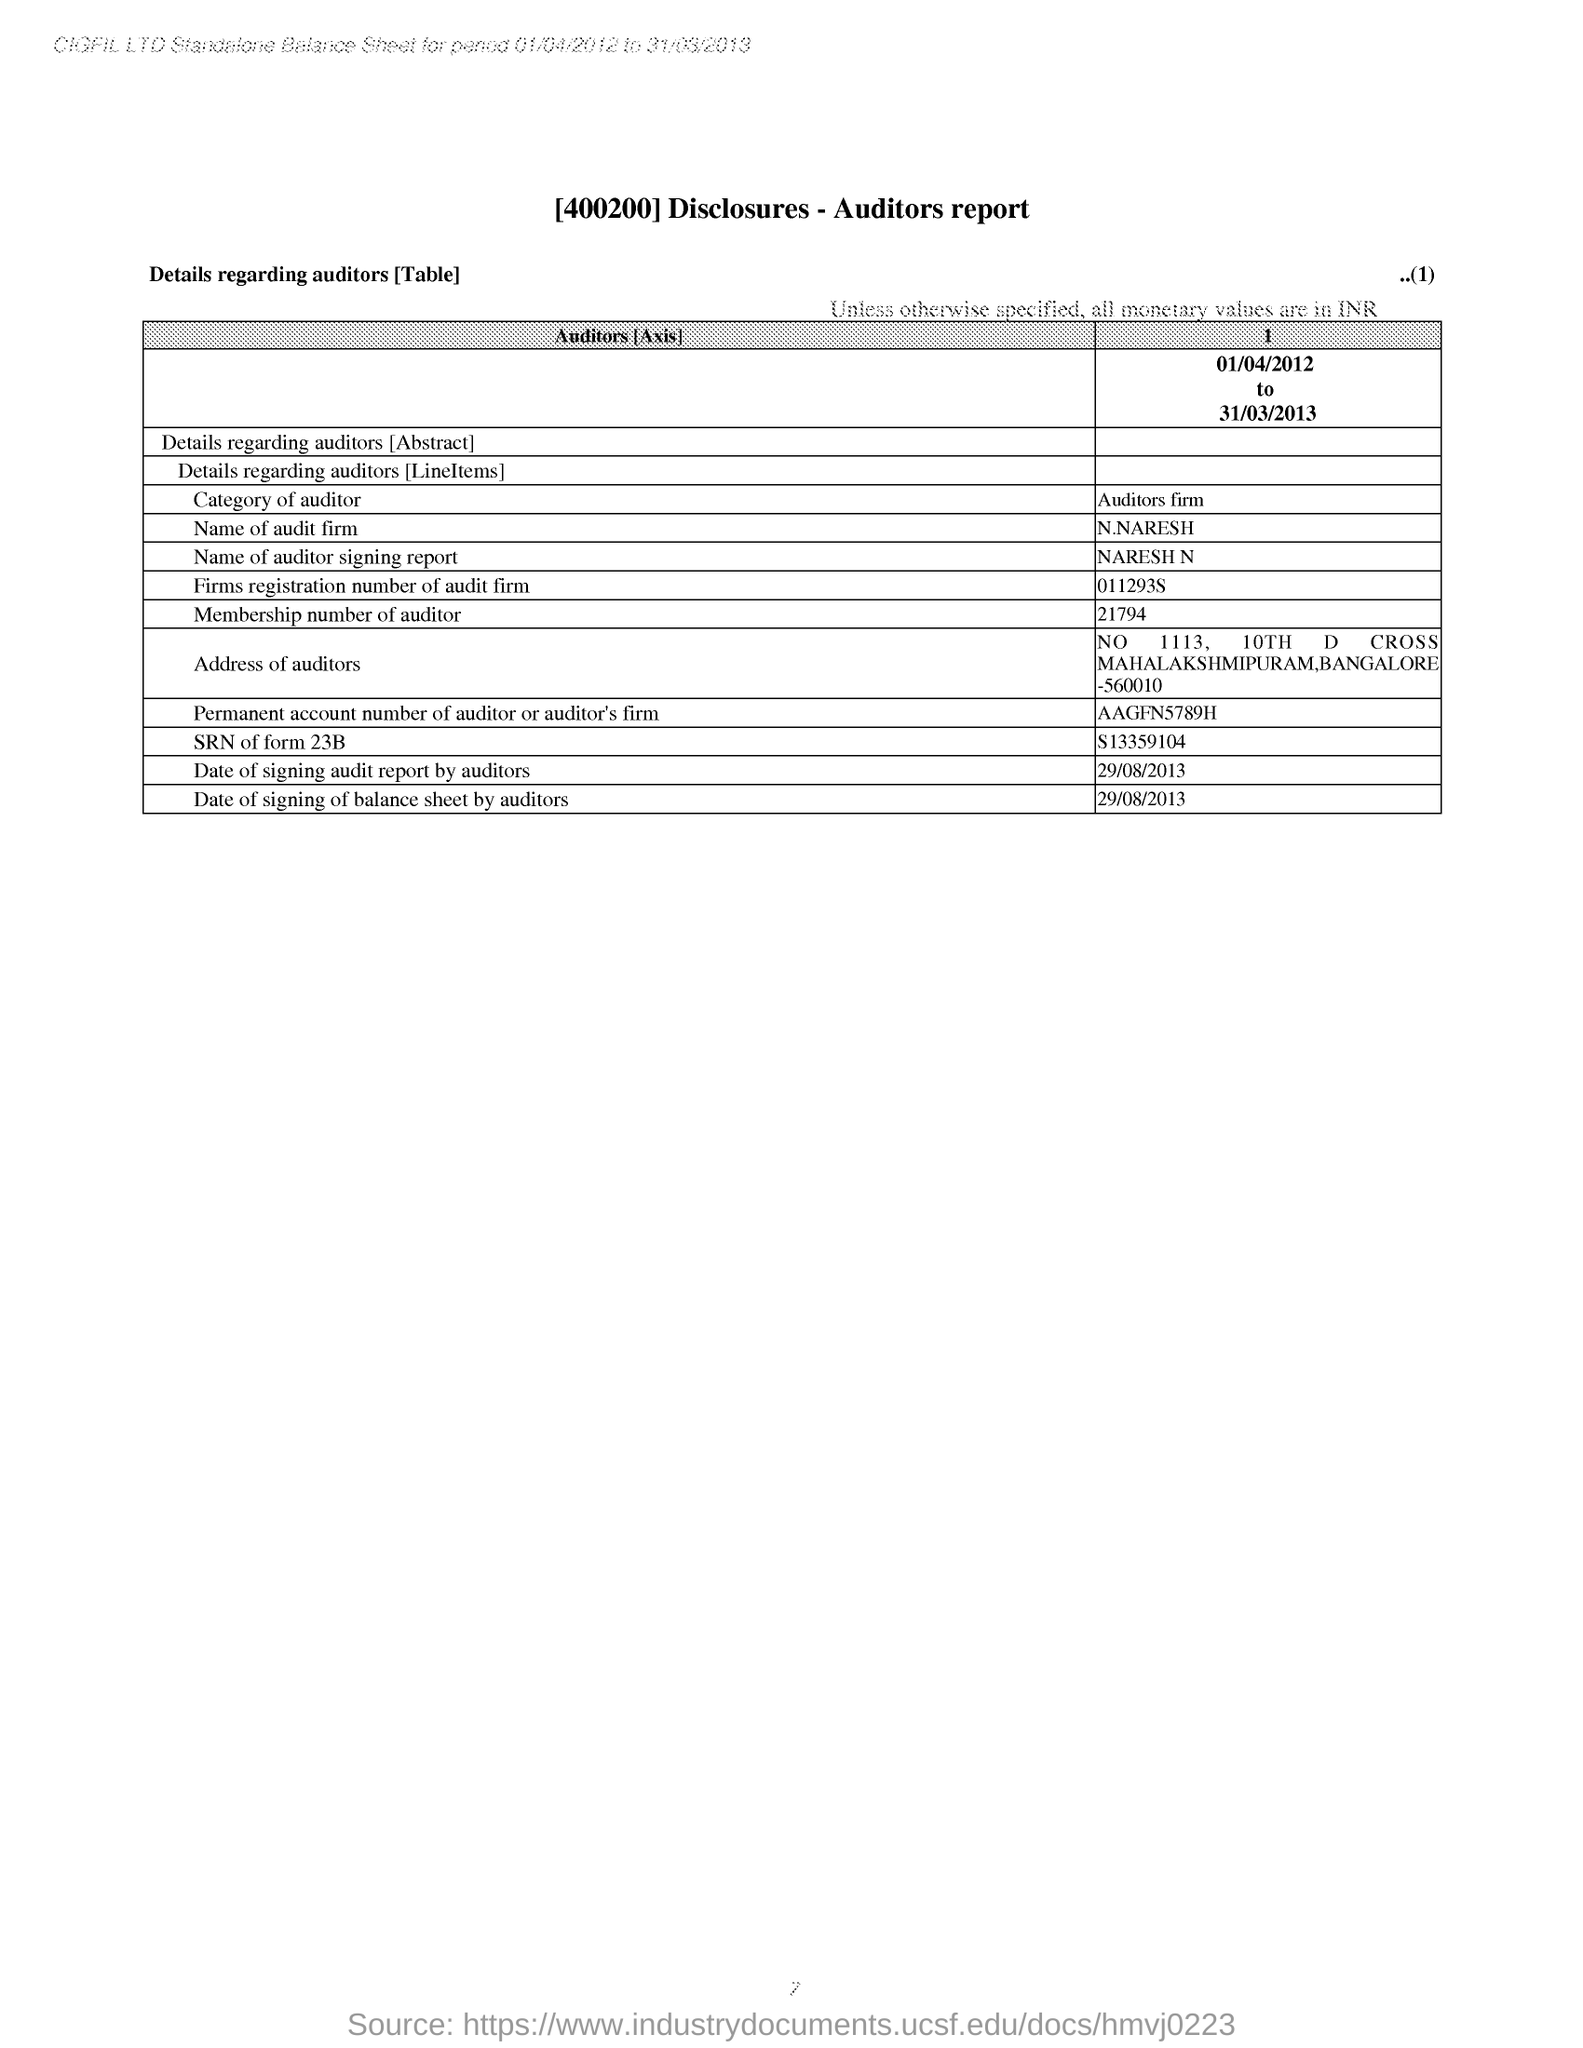Which report is mentioned in the document?
Provide a short and direct response. Auditors report. What is the city mentioned in the address of the auditor?
Offer a terse response. Bangalore. What is the category of auditor mentioned in the report?
Provide a short and direct response. Auditors firm. 